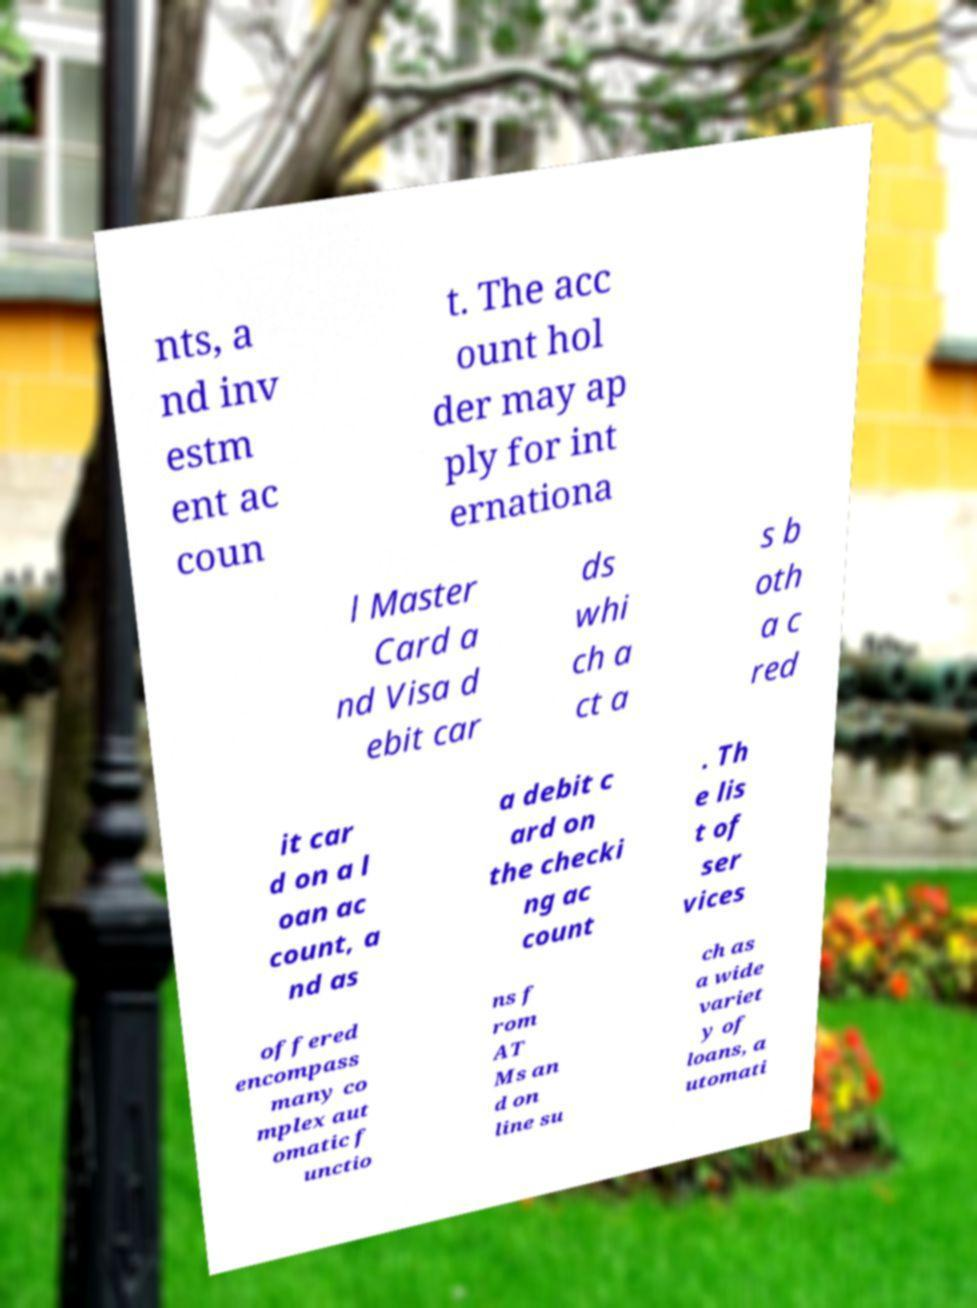Please read and relay the text visible in this image. What does it say? nts, a nd inv estm ent ac coun t. The acc ount hol der may ap ply for int ernationa l Master Card a nd Visa d ebit car ds whi ch a ct a s b oth a c red it car d on a l oan ac count, a nd as a debit c ard on the checki ng ac count . Th e lis t of ser vices offered encompass many co mplex aut omatic f unctio ns f rom AT Ms an d on line su ch as a wide variet y of loans, a utomati 